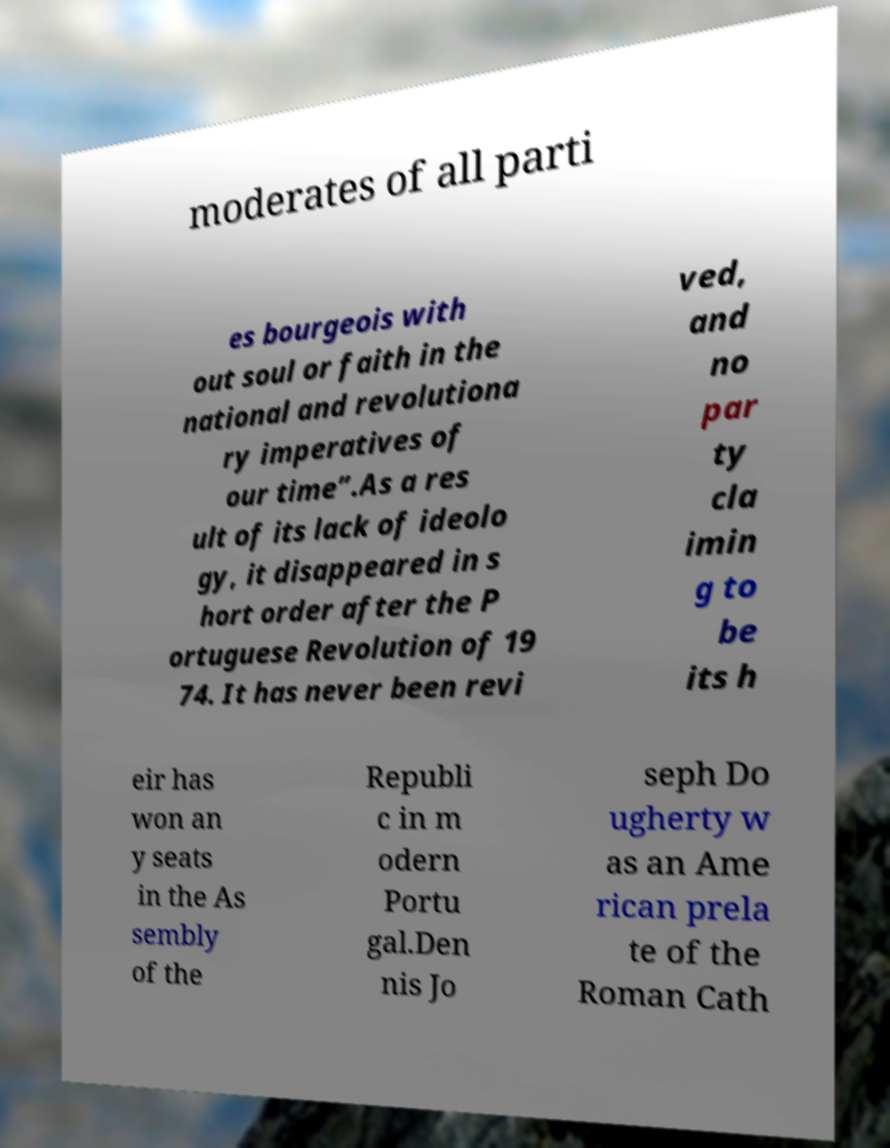There's text embedded in this image that I need extracted. Can you transcribe it verbatim? moderates of all parti es bourgeois with out soul or faith in the national and revolutiona ry imperatives of our time”.As a res ult of its lack of ideolo gy, it disappeared in s hort order after the P ortuguese Revolution of 19 74. It has never been revi ved, and no par ty cla imin g to be its h eir has won an y seats in the As sembly of the Republi c in m odern Portu gal.Den nis Jo seph Do ugherty w as an Ame rican prela te of the Roman Cath 